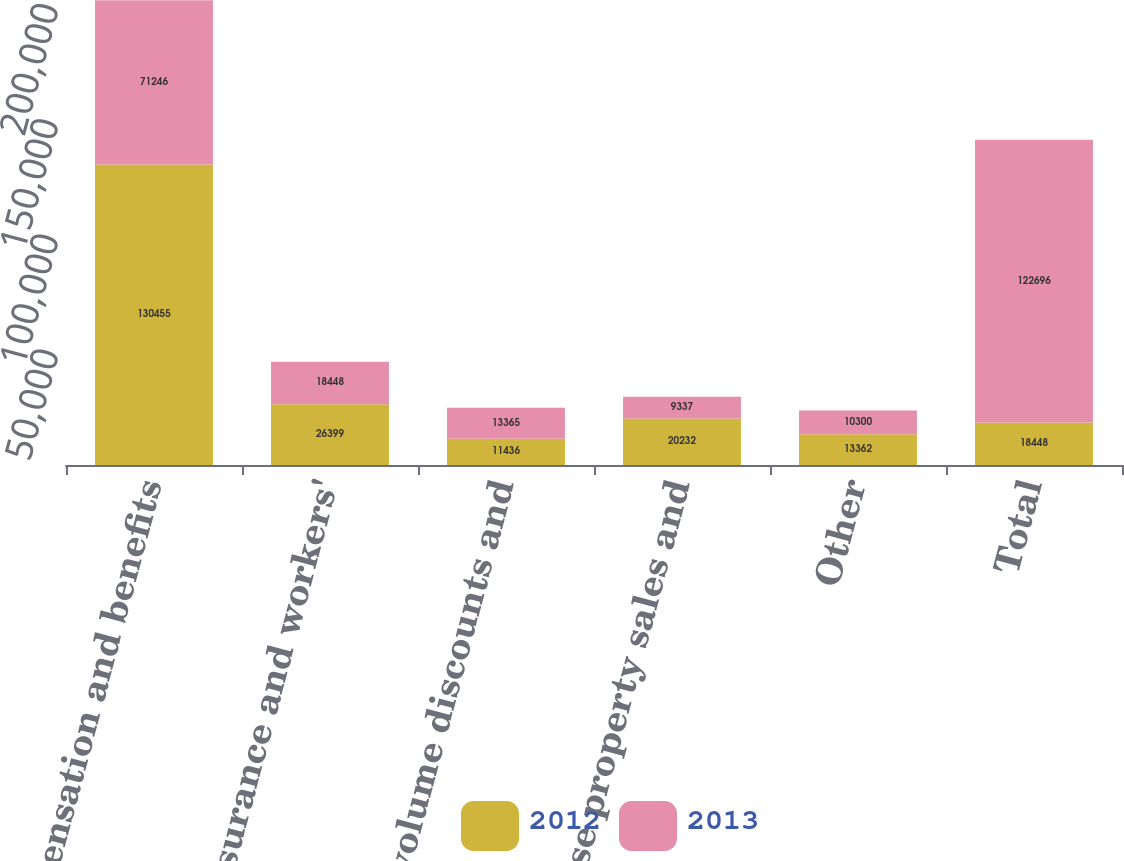Convert chart to OTSL. <chart><loc_0><loc_0><loc_500><loc_500><stacked_bar_chart><ecel><fcel>Compensation and benefits<fcel>Medical insurance and workers'<fcel>Customer volume discounts and<fcel>Franchise property sales and<fcel>Other<fcel>Total<nl><fcel>2012<fcel>130455<fcel>26399<fcel>11436<fcel>20232<fcel>13362<fcel>18448<nl><fcel>2013<fcel>71246<fcel>18448<fcel>13365<fcel>9337<fcel>10300<fcel>122696<nl></chart> 